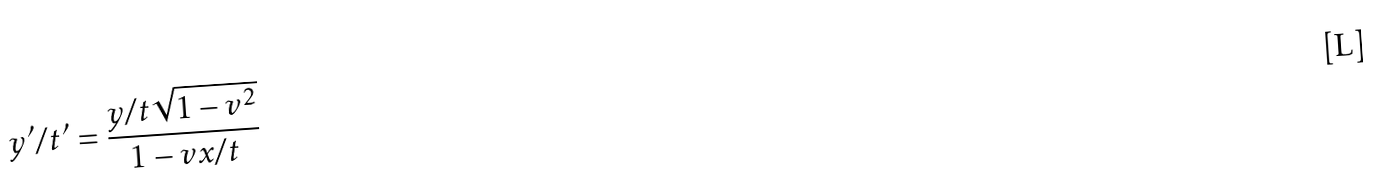<formula> <loc_0><loc_0><loc_500><loc_500>y ^ { \prime } / t ^ { \prime } = \frac { y / t \sqrt { 1 - v ^ { 2 } } } { 1 - v x / t }</formula> 